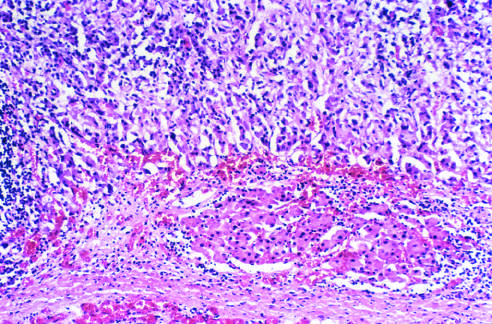does the tumor dwarf the kidney and compresse the upper pole?
Answer the question using a single word or phrase. Yes 